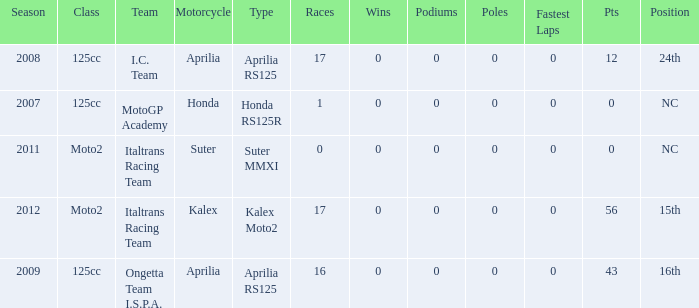Give me the full table as a dictionary. {'header': ['Season', 'Class', 'Team', 'Motorcycle', 'Type', 'Races', 'Wins', 'Podiums', 'Poles', 'Fastest Laps', 'Pts', 'Position'], 'rows': [['2008', '125cc', 'I.C. Team', 'Aprilia', 'Aprilia RS125', '17', '0', '0', '0', '0', '12', '24th'], ['2007', '125cc', 'MotoGP Academy', 'Honda', 'Honda RS125R', '1', '0', '0', '0', '0', '0', 'NC'], ['2011', 'Moto2', 'Italtrans Racing Team', 'Suter', 'Suter MMXI', '0', '0', '0', '0', '0', '0', 'NC'], ['2012', 'Moto2', 'Italtrans Racing Team', 'Kalex', 'Kalex Moto2', '17', '0', '0', '0', '0', '56', '15th'], ['2009', '125cc', 'Ongetta Team I.S.P.A.', 'Aprilia', 'Aprilia RS125', '16', '0', '0', '0', '0', '43', '16th']]} What's the number of poles in the season where the team had a Kalex motorcycle? 0.0. 